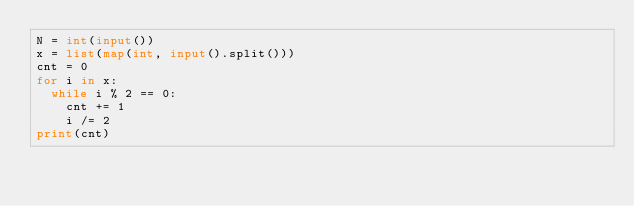<code> <loc_0><loc_0><loc_500><loc_500><_Python_>N = int(input())
x = list(map(int, input().split()))
cnt = 0
for i in x:
  while i % 2 == 0:
    cnt += 1
    i /= 2
print(cnt)</code> 